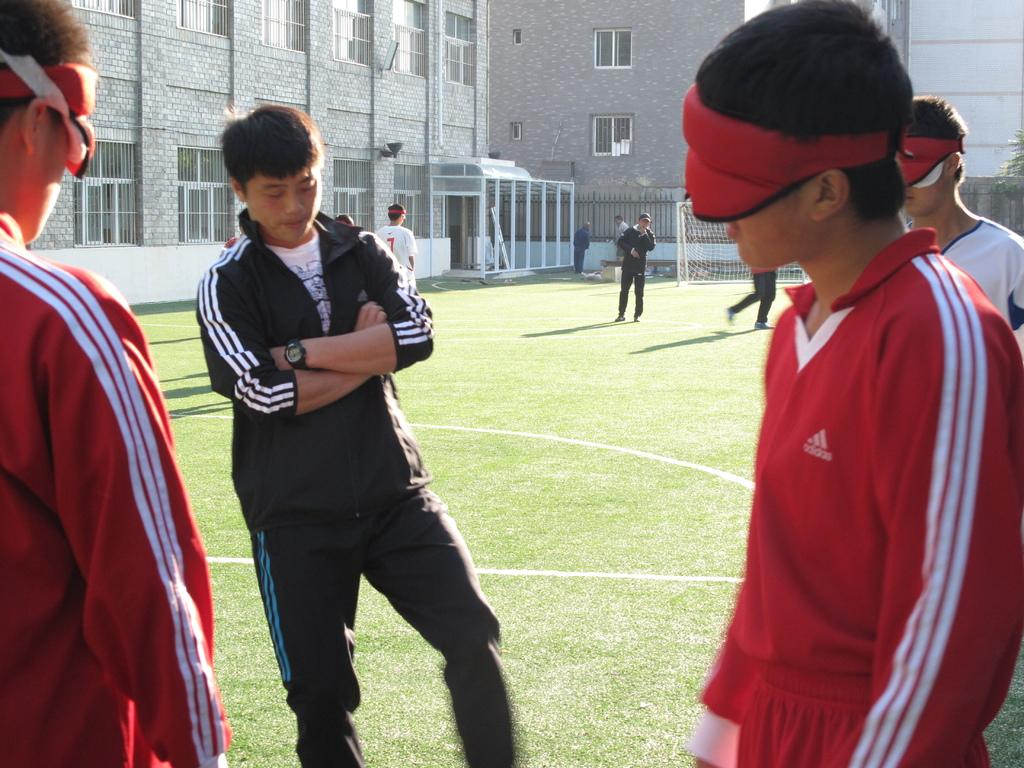How many people are in the image? There is a group of people in the image. What are some of the people doing in the image? Some people are standing on the grass, and some people are walking. What can be seen in the background of the image? There is a net, buildings, and metal rods in the background of the image. How many fish are swimming in the image? There are no fish present in the image. Are the sisters in the image holding hands? There is no mention of sisters in the image, and no indication that any people are holding hands. 